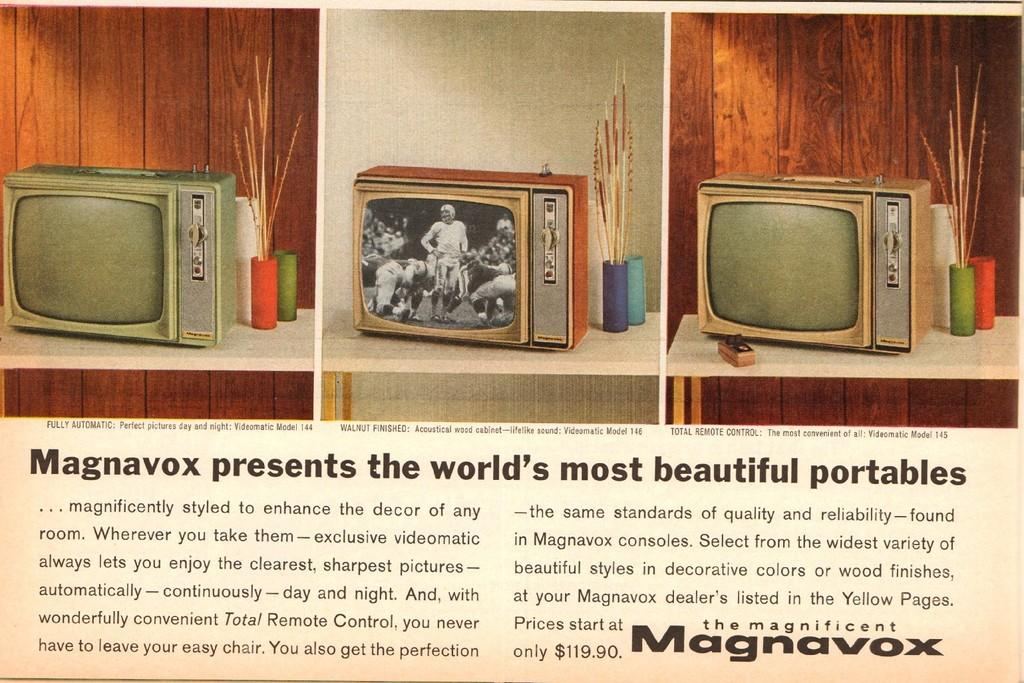<image>
Describe the image concisely. a Magnavox ad that talks about different portables 